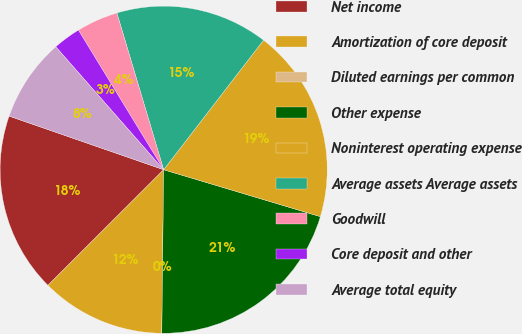<chart> <loc_0><loc_0><loc_500><loc_500><pie_chart><fcel>Net income<fcel>Amortization of core deposit<fcel>Diluted earnings per common<fcel>Other expense<fcel>Noninterest operating expense<fcel>Average assets Average assets<fcel>Goodwill<fcel>Core deposit and other<fcel>Average total equity<nl><fcel>17.81%<fcel>12.33%<fcel>0.0%<fcel>20.55%<fcel>19.18%<fcel>15.07%<fcel>4.11%<fcel>2.74%<fcel>8.22%<nl></chart> 